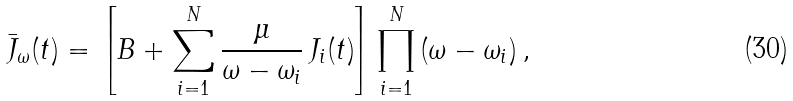Convert formula to latex. <formula><loc_0><loc_0><loc_500><loc_500>\bar { J } _ { \omega } ( t ) = \left [ { B } + \sum _ { i = 1 } ^ { N } \frac { \mu } { \omega - \omega _ { i } } \, { J } _ { i } ( t ) \right ] \prod _ { i = 1 } ^ { N } \, ( \omega - \omega _ { i } ) \, ,</formula> 